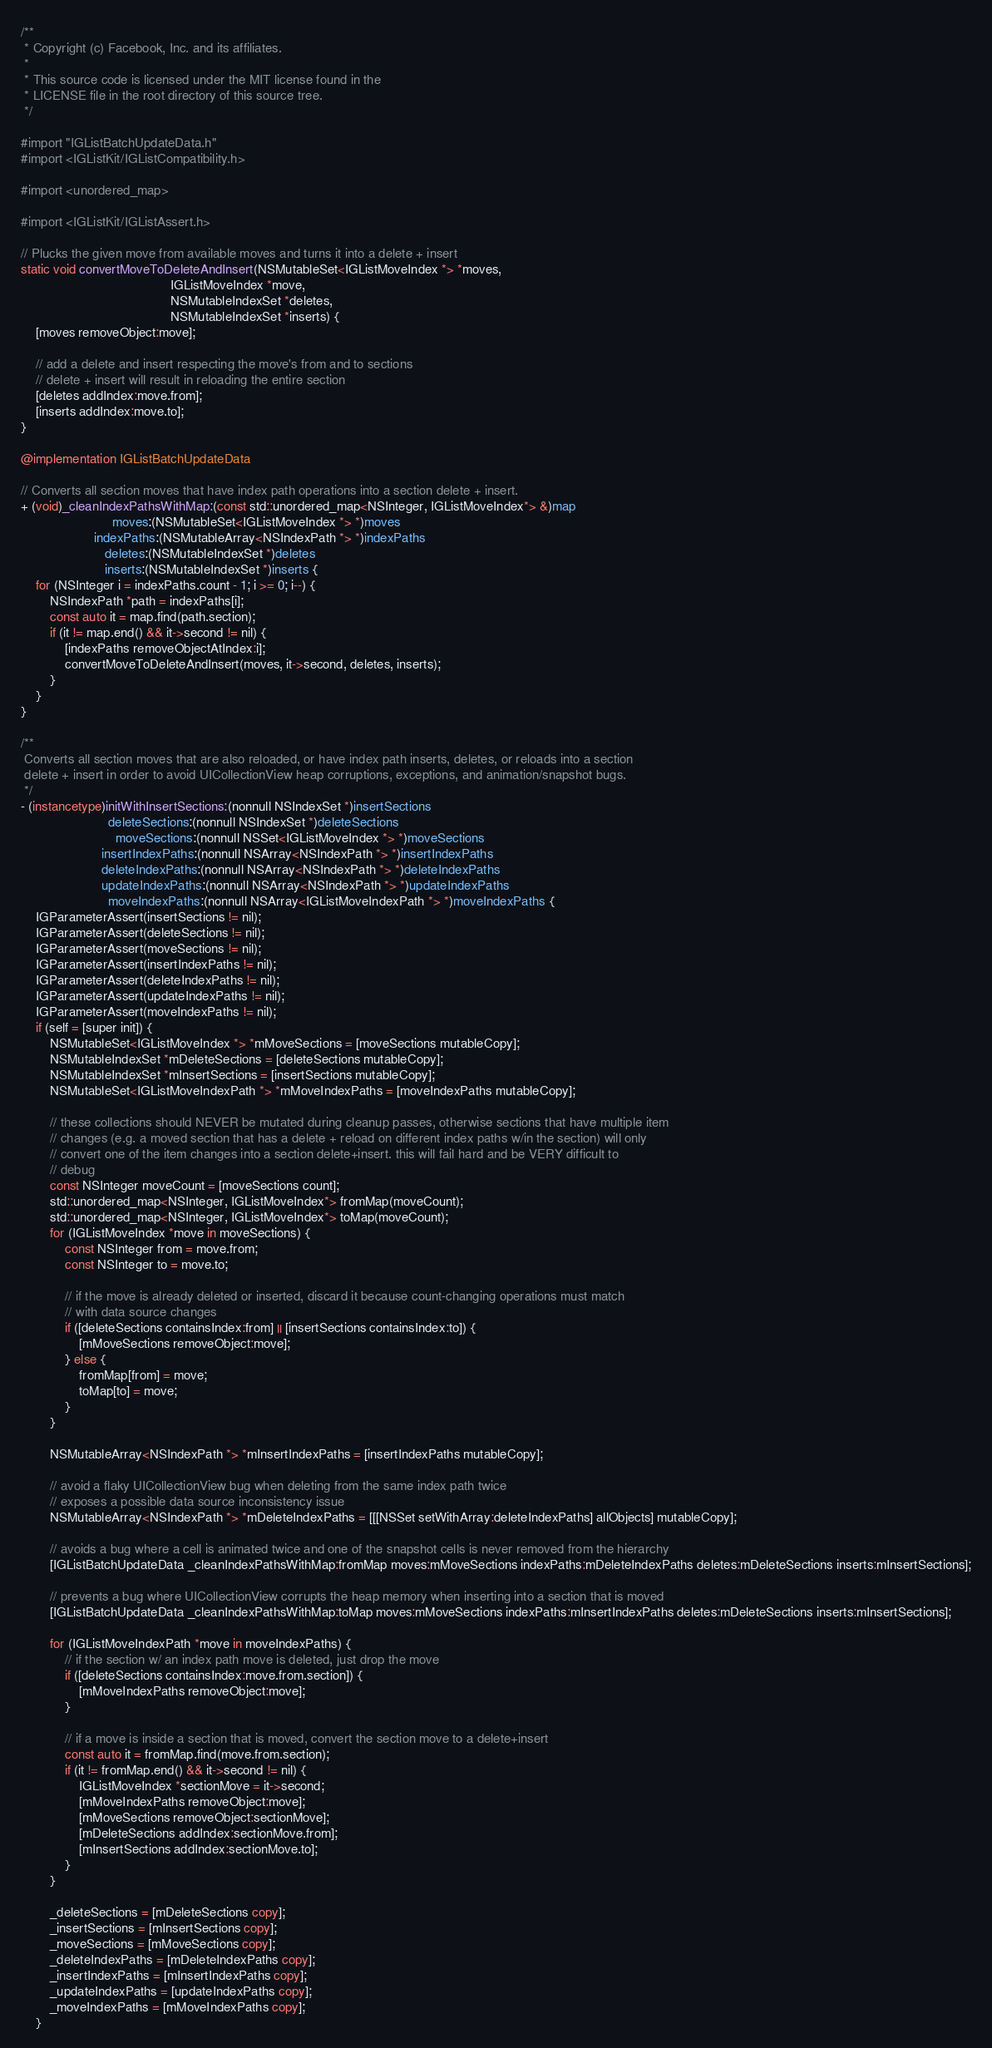Convert code to text. <code><loc_0><loc_0><loc_500><loc_500><_ObjectiveC_>/**
 * Copyright (c) Facebook, Inc. and its affiliates.
 *
 * This source code is licensed under the MIT license found in the
 * LICENSE file in the root directory of this source tree.
 */

#import "IGListBatchUpdateData.h"
#import <IGListKit/IGListCompatibility.h>

#import <unordered_map>

#import <IGListKit/IGListAssert.h>

// Plucks the given move from available moves and turns it into a delete + insert
static void convertMoveToDeleteAndInsert(NSMutableSet<IGListMoveIndex *> *moves,
                                         IGListMoveIndex *move,
                                         NSMutableIndexSet *deletes,
                                         NSMutableIndexSet *inserts) {
    [moves removeObject:move];

    // add a delete and insert respecting the move's from and to sections
    // delete + insert will result in reloading the entire section
    [deletes addIndex:move.from];
    [inserts addIndex:move.to];
}

@implementation IGListBatchUpdateData

// Converts all section moves that have index path operations into a section delete + insert.
+ (void)_cleanIndexPathsWithMap:(const std::unordered_map<NSInteger, IGListMoveIndex*> &)map
                         moves:(NSMutableSet<IGListMoveIndex *> *)moves
                    indexPaths:(NSMutableArray<NSIndexPath *> *)indexPaths
                       deletes:(NSMutableIndexSet *)deletes
                       inserts:(NSMutableIndexSet *)inserts {
    for (NSInteger i = indexPaths.count - 1; i >= 0; i--) {
        NSIndexPath *path = indexPaths[i];
        const auto it = map.find(path.section);
        if (it != map.end() && it->second != nil) {
            [indexPaths removeObjectAtIndex:i];
            convertMoveToDeleteAndInsert(moves, it->second, deletes, inserts);
        }
    }
}

/**
 Converts all section moves that are also reloaded, or have index path inserts, deletes, or reloads into a section
 delete + insert in order to avoid UICollectionView heap corruptions, exceptions, and animation/snapshot bugs.
 */
- (instancetype)initWithInsertSections:(nonnull NSIndexSet *)insertSections
                        deleteSections:(nonnull NSIndexSet *)deleteSections
                          moveSections:(nonnull NSSet<IGListMoveIndex *> *)moveSections
                      insertIndexPaths:(nonnull NSArray<NSIndexPath *> *)insertIndexPaths
                      deleteIndexPaths:(nonnull NSArray<NSIndexPath *> *)deleteIndexPaths
                      updateIndexPaths:(nonnull NSArray<NSIndexPath *> *)updateIndexPaths
                        moveIndexPaths:(nonnull NSArray<IGListMoveIndexPath *> *)moveIndexPaths {
    IGParameterAssert(insertSections != nil);
    IGParameterAssert(deleteSections != nil);
    IGParameterAssert(moveSections != nil);
    IGParameterAssert(insertIndexPaths != nil);
    IGParameterAssert(deleteIndexPaths != nil);
    IGParameterAssert(updateIndexPaths != nil);
    IGParameterAssert(moveIndexPaths != nil);
    if (self = [super init]) {
        NSMutableSet<IGListMoveIndex *> *mMoveSections = [moveSections mutableCopy];
        NSMutableIndexSet *mDeleteSections = [deleteSections mutableCopy];
        NSMutableIndexSet *mInsertSections = [insertSections mutableCopy];
        NSMutableSet<IGListMoveIndexPath *> *mMoveIndexPaths = [moveIndexPaths mutableCopy];

        // these collections should NEVER be mutated during cleanup passes, otherwise sections that have multiple item
        // changes (e.g. a moved section that has a delete + reload on different index paths w/in the section) will only
        // convert one of the item changes into a section delete+insert. this will fail hard and be VERY difficult to
        // debug
        const NSInteger moveCount = [moveSections count];
        std::unordered_map<NSInteger, IGListMoveIndex*> fromMap(moveCount);
        std::unordered_map<NSInteger, IGListMoveIndex*> toMap(moveCount);
        for (IGListMoveIndex *move in moveSections) {
            const NSInteger from = move.from;
            const NSInteger to = move.to;

            // if the move is already deleted or inserted, discard it because count-changing operations must match
            // with data source changes
            if ([deleteSections containsIndex:from] || [insertSections containsIndex:to]) {
                [mMoveSections removeObject:move];
            } else {
                fromMap[from] = move;
                toMap[to] = move;
            }
        }

        NSMutableArray<NSIndexPath *> *mInsertIndexPaths = [insertIndexPaths mutableCopy];

        // avoid a flaky UICollectionView bug when deleting from the same index path twice
        // exposes a possible data source inconsistency issue
        NSMutableArray<NSIndexPath *> *mDeleteIndexPaths = [[[NSSet setWithArray:deleteIndexPaths] allObjects] mutableCopy];

        // avoids a bug where a cell is animated twice and one of the snapshot cells is never removed from the hierarchy
        [IGListBatchUpdateData _cleanIndexPathsWithMap:fromMap moves:mMoveSections indexPaths:mDeleteIndexPaths deletes:mDeleteSections inserts:mInsertSections];

        // prevents a bug where UICollectionView corrupts the heap memory when inserting into a section that is moved
        [IGListBatchUpdateData _cleanIndexPathsWithMap:toMap moves:mMoveSections indexPaths:mInsertIndexPaths deletes:mDeleteSections inserts:mInsertSections];

        for (IGListMoveIndexPath *move in moveIndexPaths) {
            // if the section w/ an index path move is deleted, just drop the move
            if ([deleteSections containsIndex:move.from.section]) {
                [mMoveIndexPaths removeObject:move];
            }

            // if a move is inside a section that is moved, convert the section move to a delete+insert
            const auto it = fromMap.find(move.from.section);
            if (it != fromMap.end() && it->second != nil) {
                IGListMoveIndex *sectionMove = it->second;
                [mMoveIndexPaths removeObject:move];
                [mMoveSections removeObject:sectionMove];
                [mDeleteSections addIndex:sectionMove.from];
                [mInsertSections addIndex:sectionMove.to];
            }
        }

        _deleteSections = [mDeleteSections copy];
        _insertSections = [mInsertSections copy];
        _moveSections = [mMoveSections copy];
        _deleteIndexPaths = [mDeleteIndexPaths copy];
        _insertIndexPaths = [mInsertIndexPaths copy];
        _updateIndexPaths = [updateIndexPaths copy];
        _moveIndexPaths = [mMoveIndexPaths copy];
    }</code> 